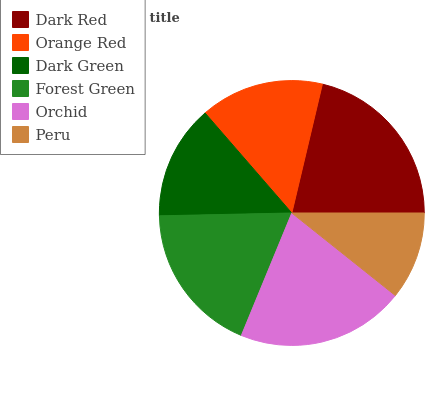Is Peru the minimum?
Answer yes or no. Yes. Is Dark Red the maximum?
Answer yes or no. Yes. Is Orange Red the minimum?
Answer yes or no. No. Is Orange Red the maximum?
Answer yes or no. No. Is Dark Red greater than Orange Red?
Answer yes or no. Yes. Is Orange Red less than Dark Red?
Answer yes or no. Yes. Is Orange Red greater than Dark Red?
Answer yes or no. No. Is Dark Red less than Orange Red?
Answer yes or no. No. Is Forest Green the high median?
Answer yes or no. Yes. Is Orange Red the low median?
Answer yes or no. Yes. Is Dark Red the high median?
Answer yes or no. No. Is Dark Red the low median?
Answer yes or no. No. 